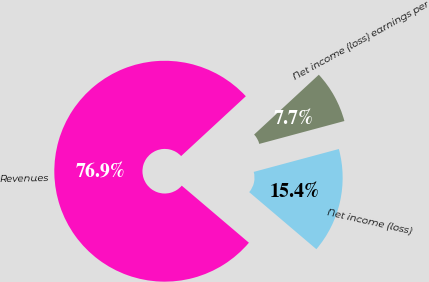<chart> <loc_0><loc_0><loc_500><loc_500><pie_chart><fcel>Revenues<fcel>Net income (loss)<fcel>Net income (loss) earnings per<nl><fcel>76.92%<fcel>15.39%<fcel>7.7%<nl></chart> 